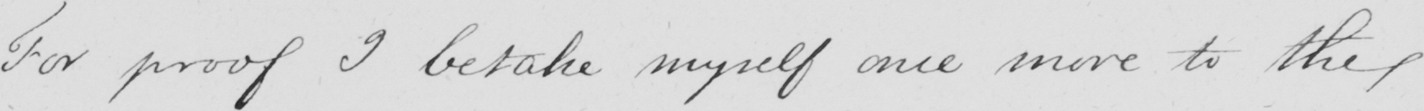What does this handwritten line say? For proof I betake myself once more to the 